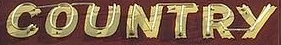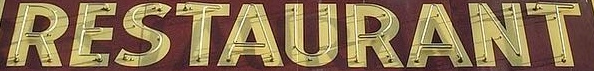What text is displayed in these images sequentially, separated by a semicolon? COUNTRY; RESTAURANT 